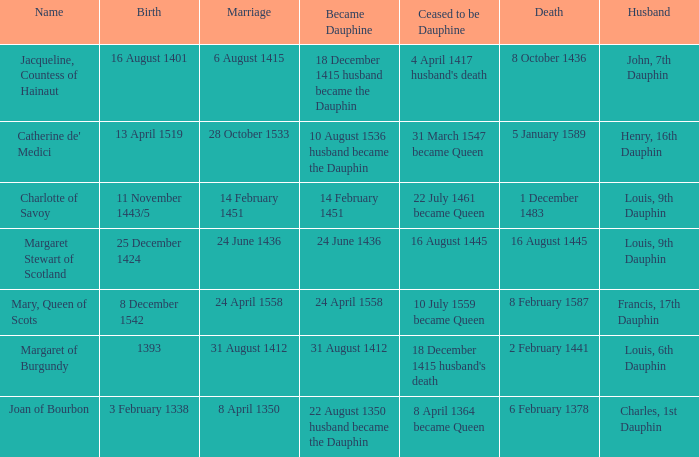Who has a birth of 16 august 1401? Jacqueline, Countess of Hainaut. 